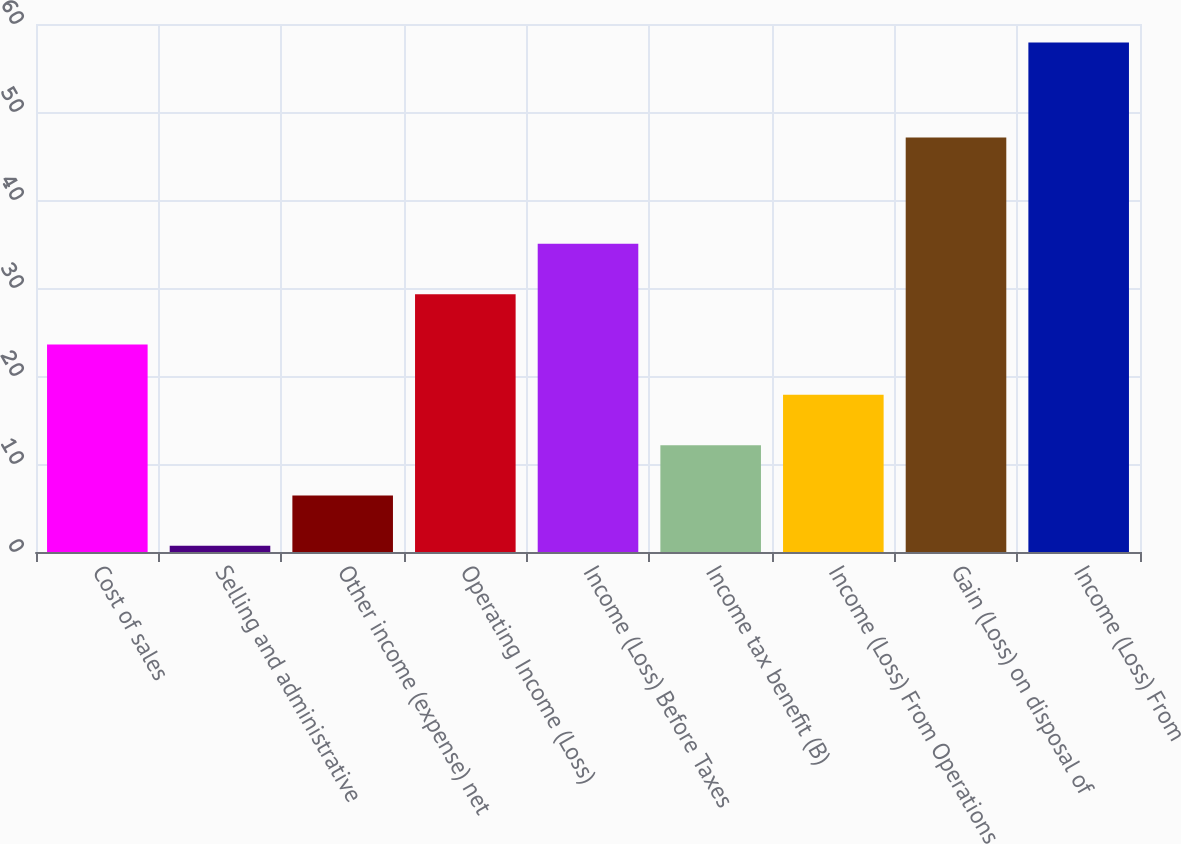<chart> <loc_0><loc_0><loc_500><loc_500><bar_chart><fcel>Cost of sales<fcel>Selling and administrative<fcel>Other income (expense) net<fcel>Operating Income (Loss)<fcel>Income (Loss) Before Taxes<fcel>Income tax benefit (B)<fcel>Income (Loss) From Operations<fcel>Gain (Loss) on disposal of<fcel>Income (Loss) From<nl><fcel>23.58<fcel>0.7<fcel>6.42<fcel>29.3<fcel>35.02<fcel>12.14<fcel>17.86<fcel>47.1<fcel>57.9<nl></chart> 